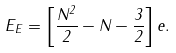<formula> <loc_0><loc_0><loc_500><loc_500>E _ { E } = \left [ \frac { N ^ { 2 } } { 2 } - N - \frac { 3 } { 2 } \right ] e .</formula> 